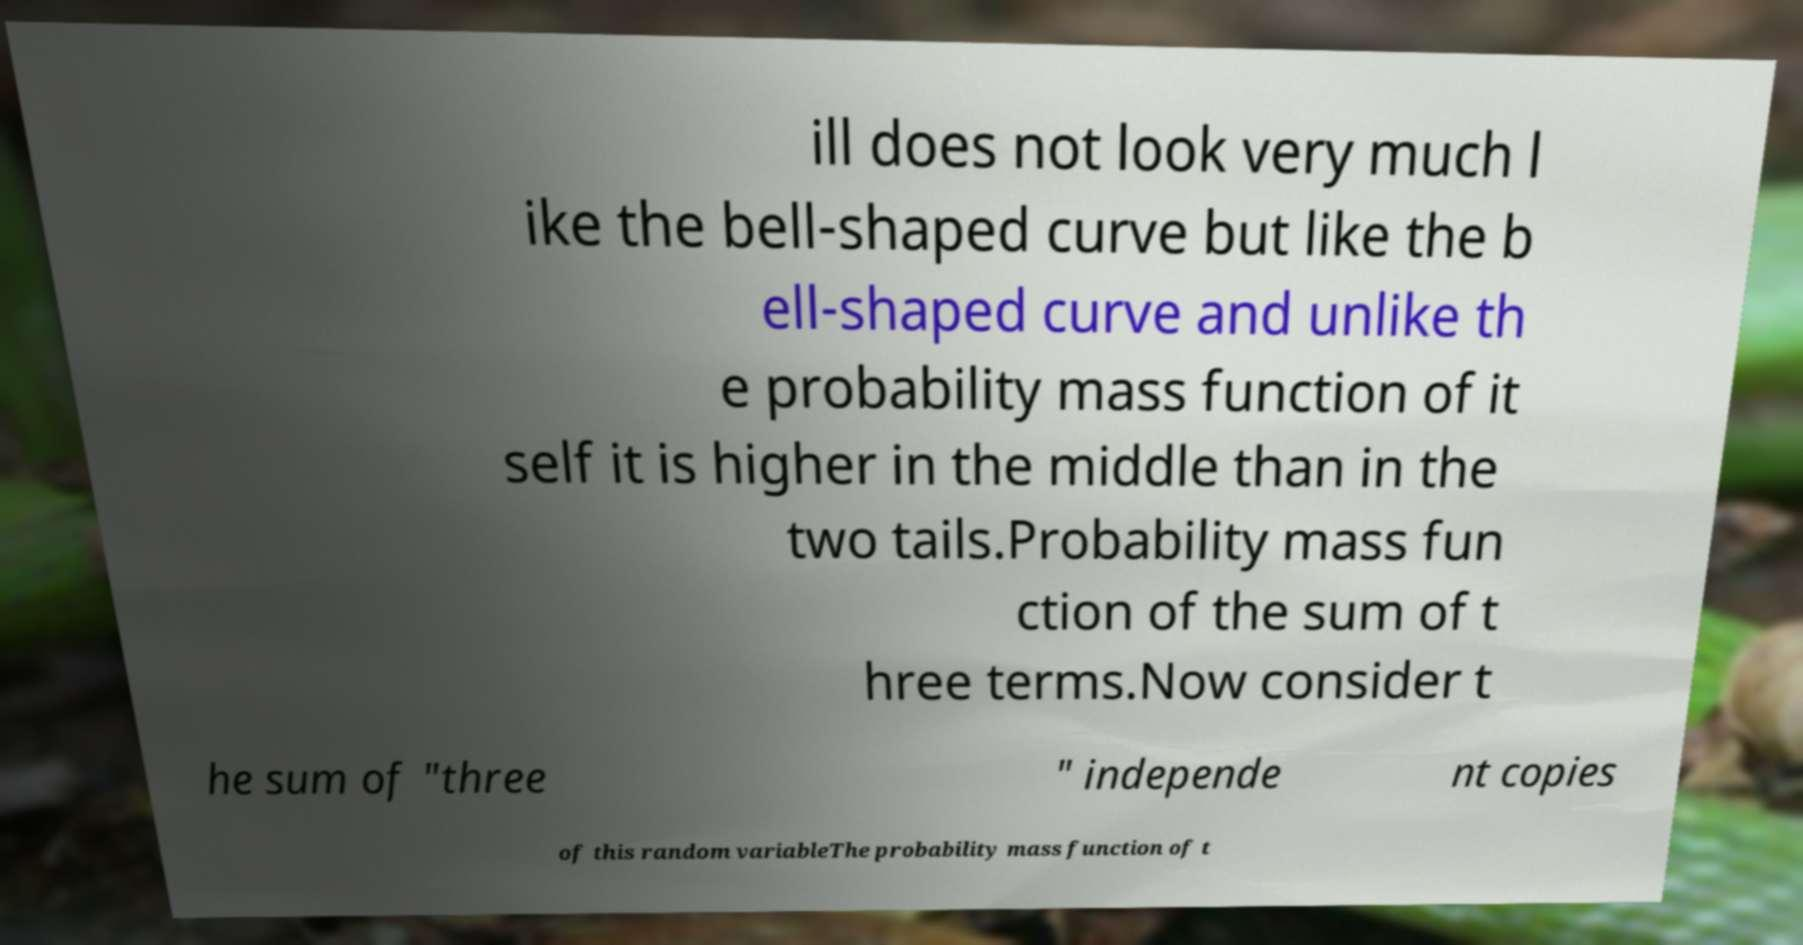Please identify and transcribe the text found in this image. ill does not look very much l ike the bell-shaped curve but like the b ell-shaped curve and unlike th e probability mass function of it self it is higher in the middle than in the two tails.Probability mass fun ction of the sum of t hree terms.Now consider t he sum of "three " independe nt copies of this random variableThe probability mass function of t 